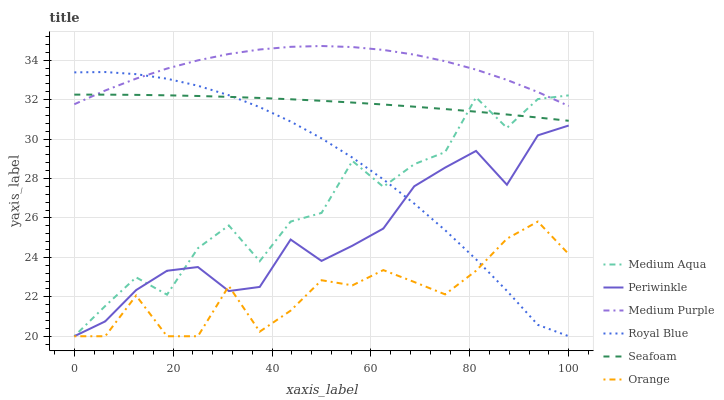Does Orange have the minimum area under the curve?
Answer yes or no. Yes. Does Medium Purple have the maximum area under the curve?
Answer yes or no. Yes. Does Royal Blue have the minimum area under the curve?
Answer yes or no. No. Does Royal Blue have the maximum area under the curve?
Answer yes or no. No. Is Seafoam the smoothest?
Answer yes or no. Yes. Is Medium Aqua the roughest?
Answer yes or no. Yes. Is Medium Purple the smoothest?
Answer yes or no. No. Is Medium Purple the roughest?
Answer yes or no. No. Does Royal Blue have the lowest value?
Answer yes or no. Yes. Does Medium Purple have the lowest value?
Answer yes or no. No. Does Medium Purple have the highest value?
Answer yes or no. Yes. Does Royal Blue have the highest value?
Answer yes or no. No. Is Orange less than Medium Purple?
Answer yes or no. Yes. Is Seafoam greater than Periwinkle?
Answer yes or no. Yes. Does Medium Aqua intersect Medium Purple?
Answer yes or no. Yes. Is Medium Aqua less than Medium Purple?
Answer yes or no. No. Is Medium Aqua greater than Medium Purple?
Answer yes or no. No. Does Orange intersect Medium Purple?
Answer yes or no. No. 